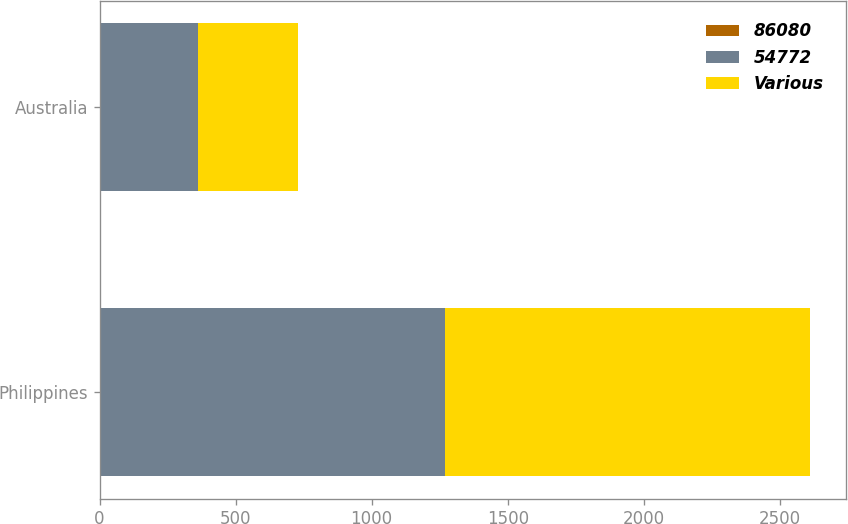<chart> <loc_0><loc_0><loc_500><loc_500><stacked_bar_chart><ecel><fcel>Philippines<fcel>Australia<nl><fcel>86080<fcel>5.81<fcel>4.5<nl><fcel>54772<fcel>1265<fcel>359<nl><fcel>Various<fcel>1341<fcel>364<nl></chart> 